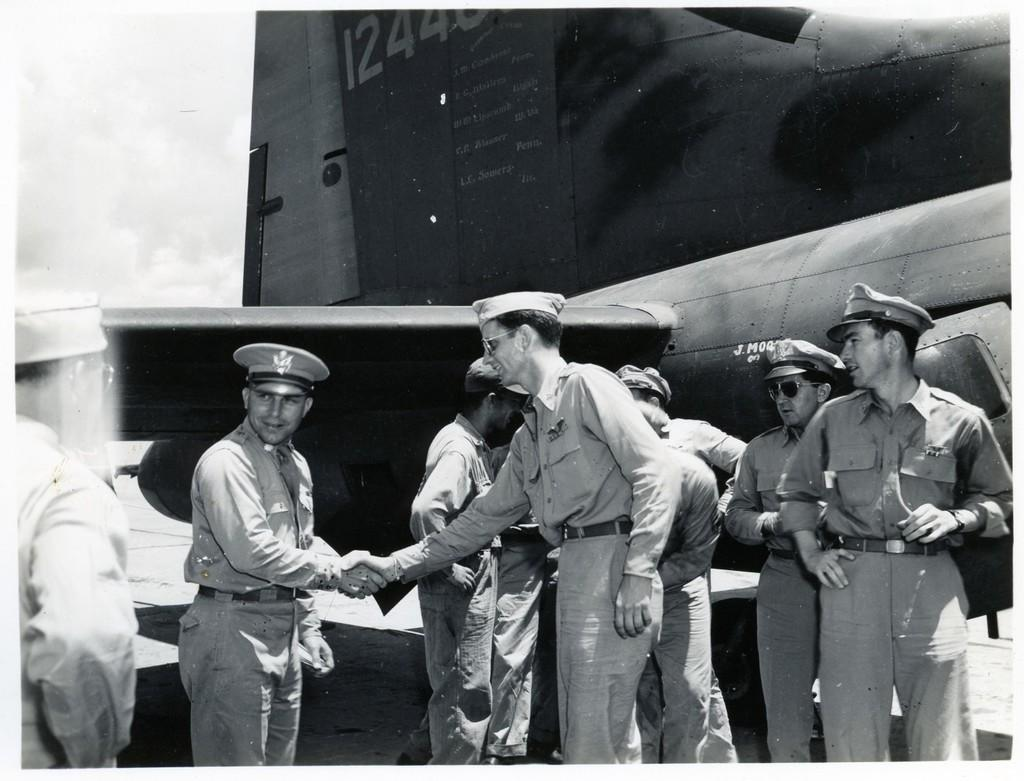<image>
Share a concise interpretation of the image provided. An airplane with a number beginning with 12 on it sits near some army men. 